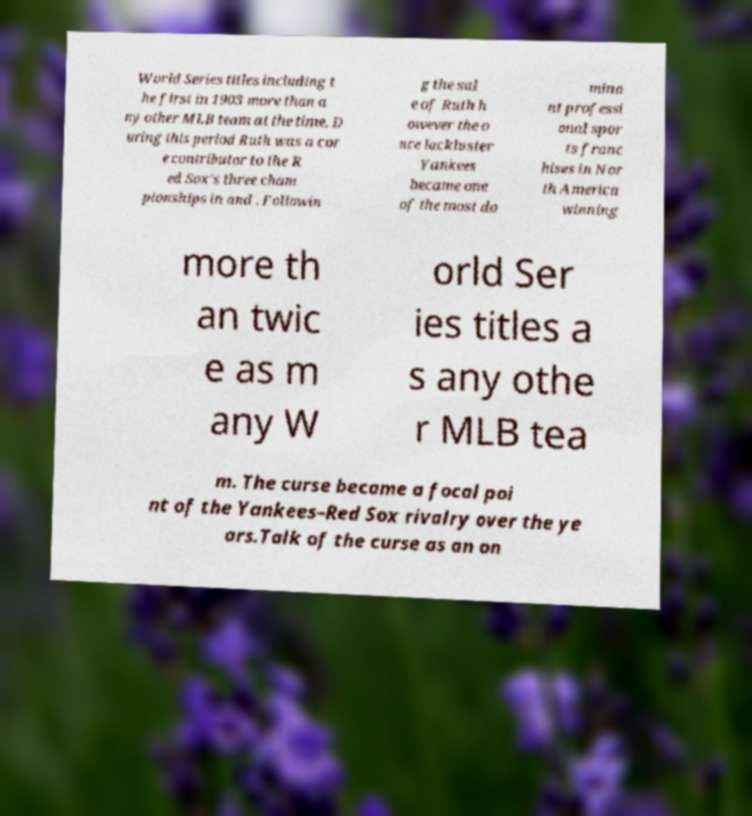Please identify and transcribe the text found in this image. World Series titles including t he first in 1903 more than a ny other MLB team at the time. D uring this period Ruth was a cor e contributor to the R ed Sox's three cham pionships in and . Followin g the sal e of Ruth h owever the o nce lackluster Yankees became one of the most do mina nt professi onal spor ts franc hises in Nor th America winning more th an twic e as m any W orld Ser ies titles a s any othe r MLB tea m. The curse became a focal poi nt of the Yankees–Red Sox rivalry over the ye ars.Talk of the curse as an on 